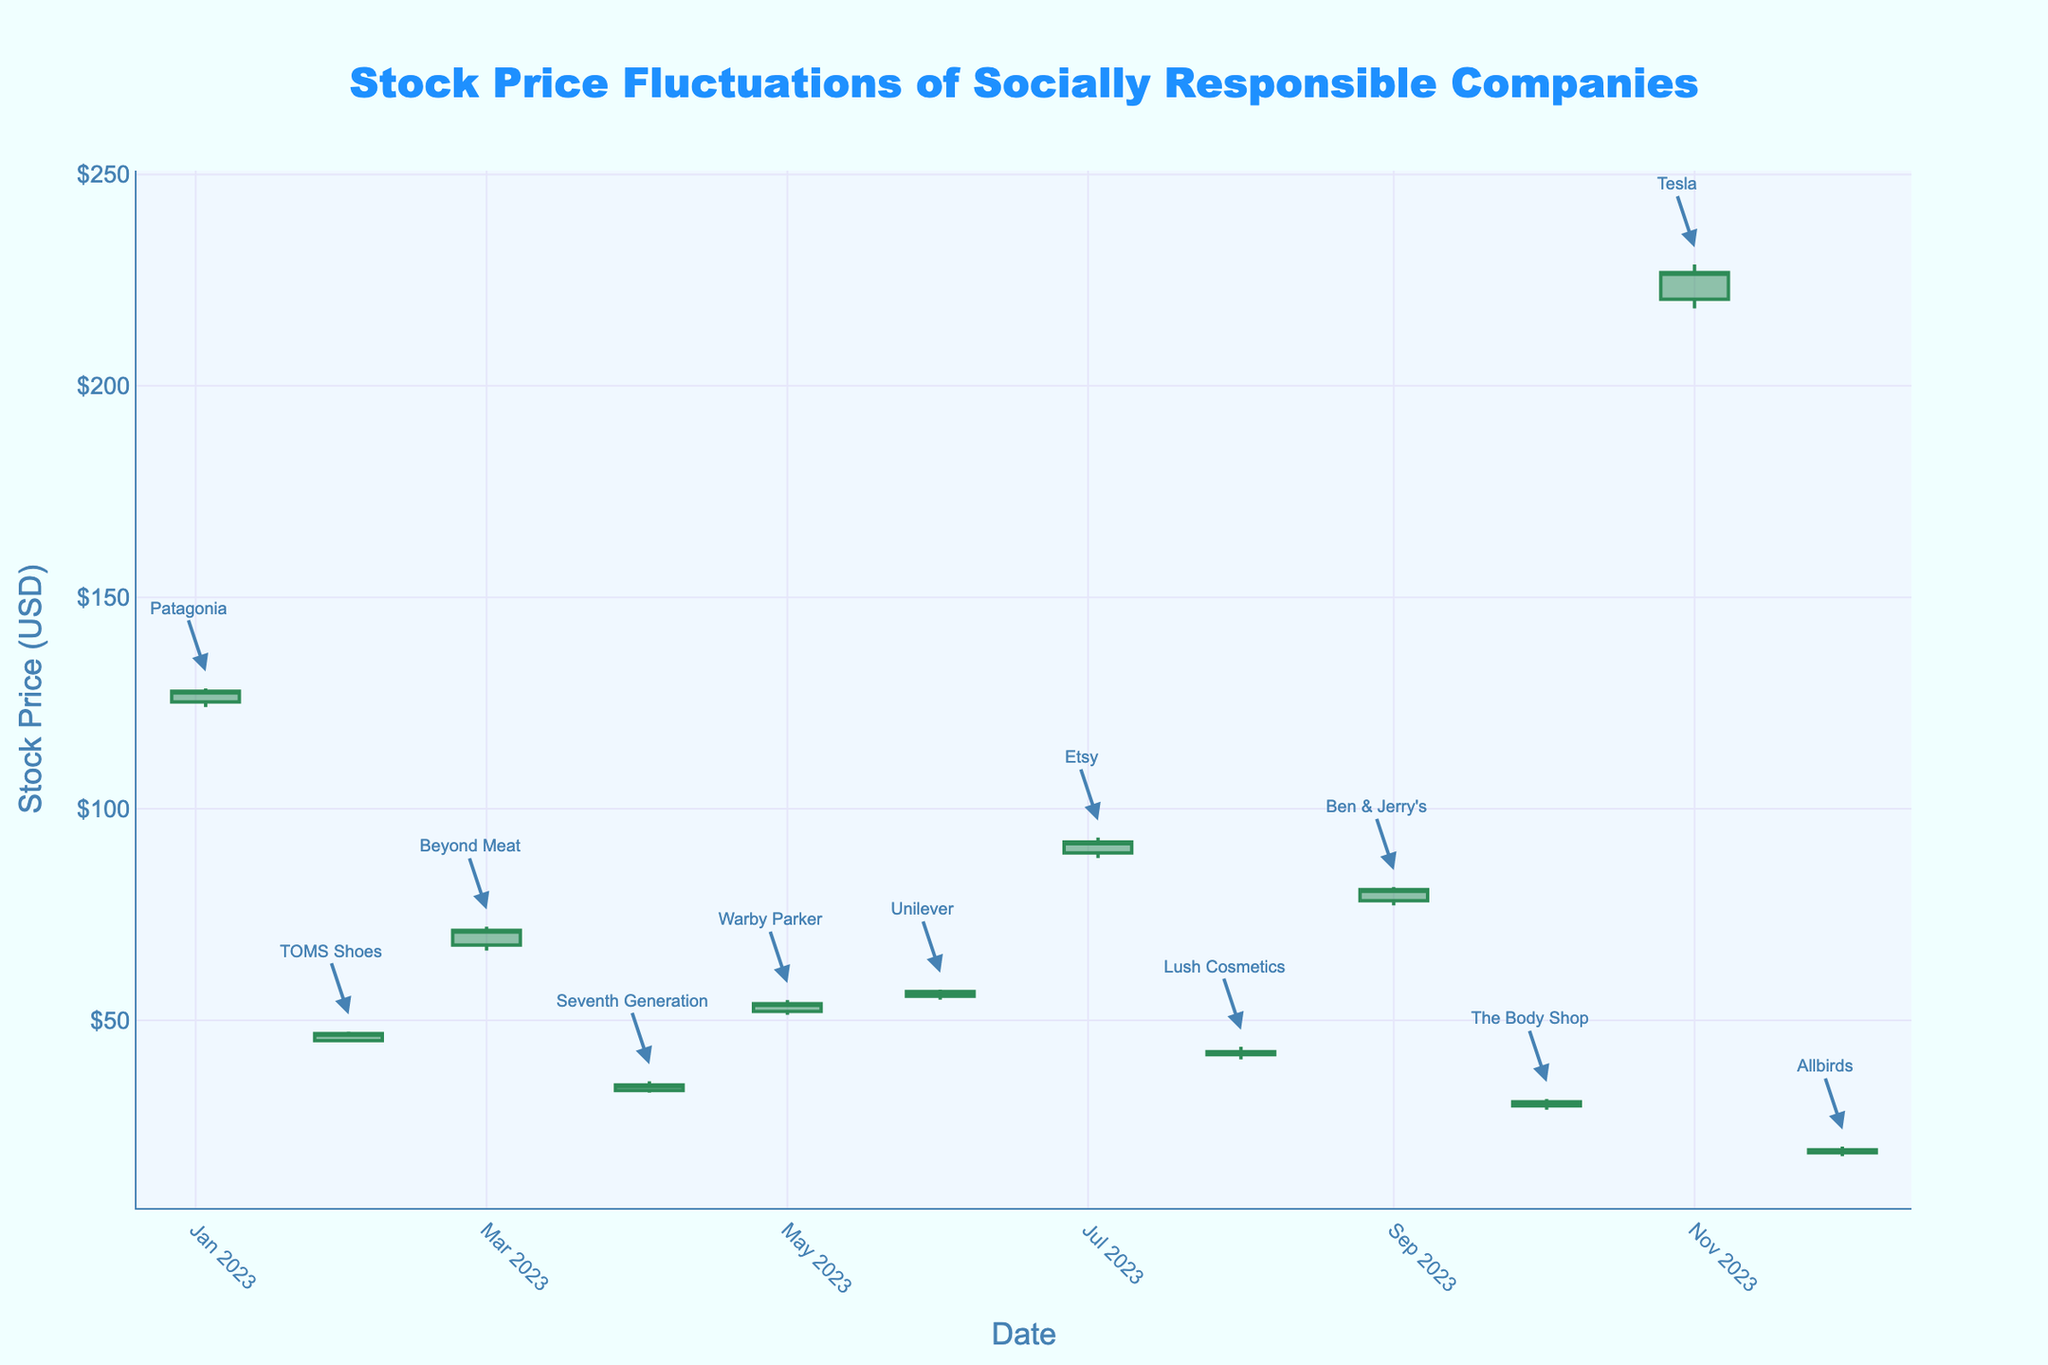What's the overall trend in stock prices for socially responsible companies over the fiscal year? By examining the OHLC chart, we can observe that most companies show an upward or stable trend in their stock prices over the year. This is determined by looking at the "Open" and "Close" price points for each month and noting whether the closing prices are generally higher than the opening prices over time.
Answer: Mostly upward or stable trend Which company had the highest closing stock price, and when? Looking at the OHLC chart, the annotations, and the "Close" prices for each company, Tesla had the highest closing stock price. This can be seen on the date 2023-11-01, where Tesla had a closing price of $226.80.
Answer: Tesla in November What was the highest stock price recorded among all companies and who achieved it? To find the highest stock price, refer to the "High" values on the OHLC chart. The company with the highest recorded stock price is Tesla, which had a high of $228.70 on 2023-11-01.
Answer: $228.70 by Tesla Which company experienced the greatest volatility in a single month? Volatility can be measured by the difference between "High" and "Low" prices. By looking at the chart, Beyond Meat showed the greatest volatility with a high of $72.15 and a low of $66.50 in March, a difference of $5.65.
Answer: Beyond Meat in March Compared to Unilever in June, did Beyond Meat in March close at a higher or lower price? By comparing the "Close" prices of Unilever in June ($56.80) and Beyond Meat in March ($71.30), Beyond Meat closed at a higher price.
Answer: Higher How did the stock price of TOMS Shoes change from opening to closing in February? To determine the change, compare the "Open" price ($45.20) and the "Close" price ($46.90). The TOMS Shoes stock price increased by $1.70.
Answer: Increased by $1.70 Which two companies have the closest closing prices, and what are those values? By comparing all "Close" prices, Lush Cosmetics and The Body Shop have the closest closing prices, with Lush Cosmetics at $42.60 and The Body Shop at $30.75, indicating the smallest difference relative to others.
Answer: Lush Cosmetics and The Body Shop with $42.60 and $30.75 What month did Etsy achieve its highest stock price and what was it? From the chart, locate the month where Etsy reaches its highest point. In July, Etsy hit a high of $93.20.
Answer: July, $93.20 What is the average closing price of companies in Q1 (January to March)? The closing prices for Q1 are for Patagonia in January ($127.80), TOMS Shoes in February ($46.90), and Beyond Meat in March ($71.30). Summing these gives $245.80. Dividing by 3, the average closing price is approximately $81.93.
Answer: $81.93 Which company's stock price showed the least fluctuation between its opening and closing prices? The fluctuation is calculated by the absolute difference between the "Open" and "Close" prices. Unilever in June shows the least fluctuation with a difference of $1.10.
Answer: Unilever in June 